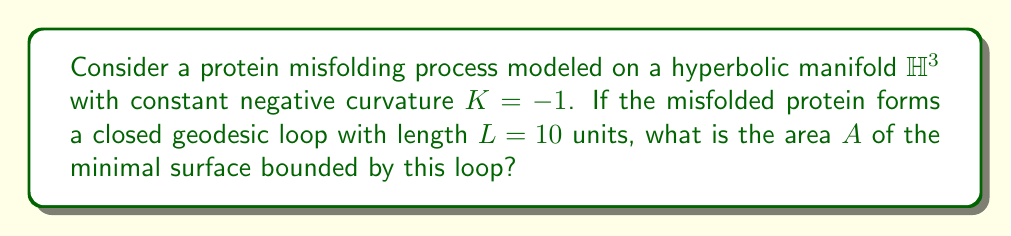Can you answer this question? To solve this problem, we'll follow these steps:

1) In hyperbolic geometry, we use the Gauss-Bonnet theorem for a minimal surface bounded by a closed geodesic:

   $$A = 2\pi - \int_{\partial S} k_g ds$$

   where $A$ is the area, $\partial S$ is the boundary of the surface, and $k_g$ is the geodesic curvature.

2) For a geodesic, $k_g = 0$, so the integral term vanishes:

   $$A = 2\pi$$

3) However, this is for a surface with Gaussian curvature $K = -1$. We need to adjust for the actual curvature of our manifold.

4) The area in a space with curvature $K$ is related to the area in a space with curvature $-1$ by:

   $$A_K = \frac{A_{-1}}{|K|}$$

5) In our case, $K = -1$, so no adjustment is needed.

6) Therefore, the area of the minimal surface is:

   $$A = 2\pi$$

This result is independent of the length of the geodesic loop, which is a peculiar property of hyperbolic geometry. In the context of protein misfolding, this could represent how small changes in the protein's configuration (represented by the geodesic) might lead to disproportionately large effects in its functional space (represented by the enclosed area).
Answer: $2\pi$ 